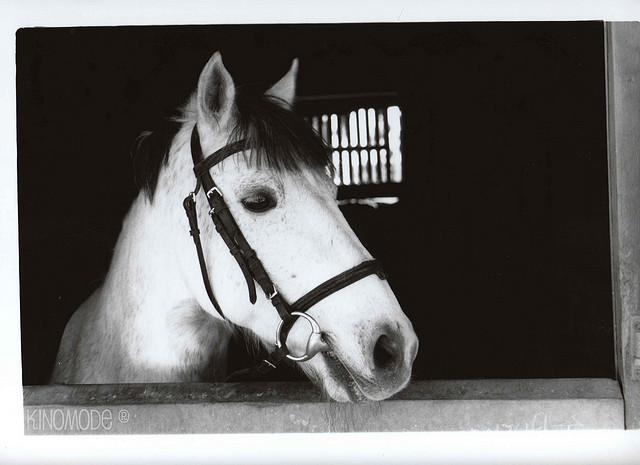What color is the horse?
Concise answer only. White. Is the horse inside or outside?
Be succinct. Inside. Is there any people in the picture?
Short answer required. No. 